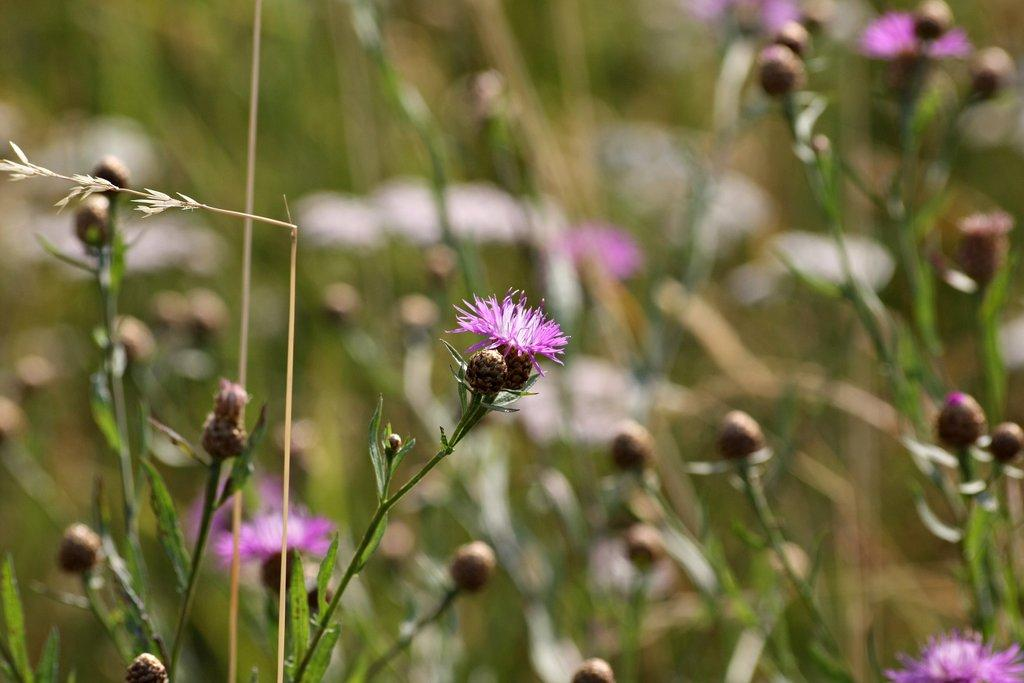What type of plants can be seen in the image? There are flower plants in the image. What type of sidewalk can be seen in the image? There is no sidewalk present in the image; it only features flower plants. 